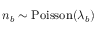Convert formula to latex. <formula><loc_0><loc_0><loc_500><loc_500>n _ { b } \sim P o i s s o n ( \lambda _ { b } )</formula> 